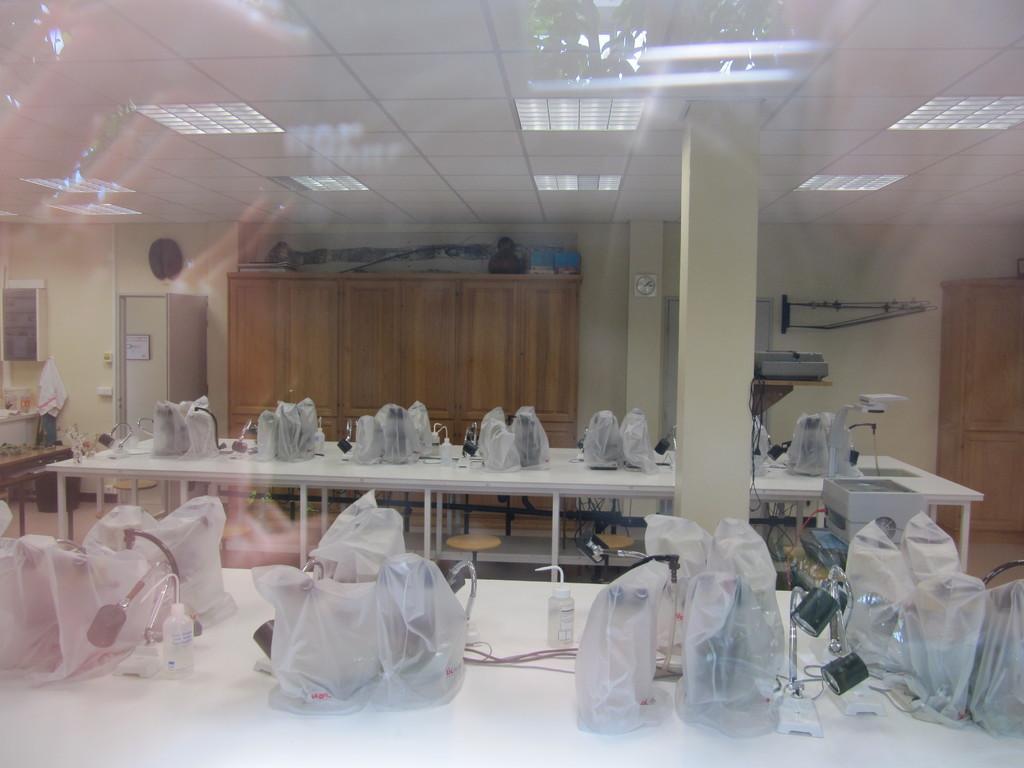Describe this image in one or two sentences. In this picture I can see number of tables on which there are things which are covered with plastic covers and I see few more things. In the background I can see the cabinets and few equipment. On the top of this picture I can see the ceiling on which there are lights and I see 2 pillars in the center. 